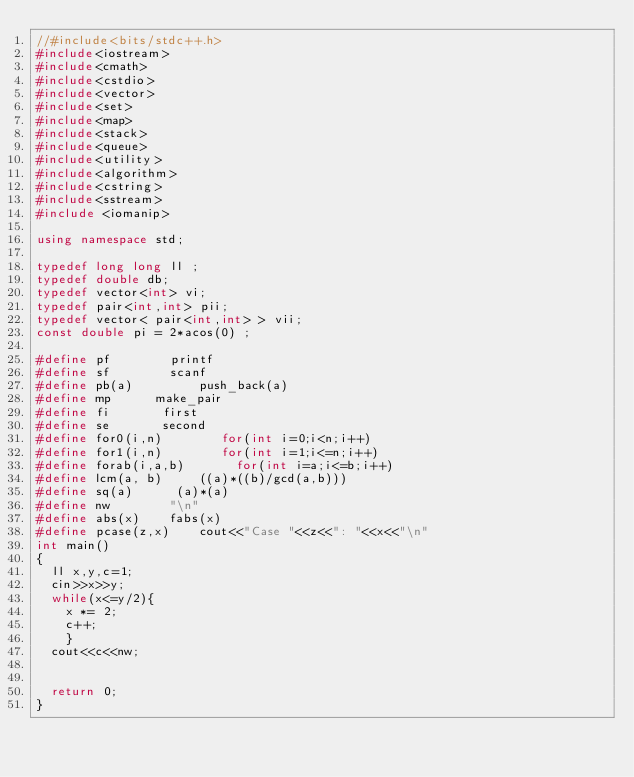<code> <loc_0><loc_0><loc_500><loc_500><_C++_>//#include<bits/stdc++.h>
#include<iostream>
#include<cmath>
#include<cstdio>
#include<vector>
#include<set>
#include<map>
#include<stack>
#include<queue>
#include<utility>
#include<algorithm>
#include<cstring>
#include<sstream>
#include <iomanip>

using namespace std;

typedef long long ll ;
typedef double db;
typedef vector<int> vi;
typedef pair<int,int> pii;
typedef vector< pair<int,int> > vii;
const double pi = 2*acos(0) ;

#define pf		  	printf
#define sf			  scanf
#define pb(a)         push_back(a)
#define mp			make_pair
#define fi			 first
#define se			 second
#define for0(i,n)        for(int i=0;i<n;i++)
#define for1(i,n)        for(int i=1;i<=n;i++)
#define forab(i,a,b)       for(int i=a;i<=b;i++)
#define lcm(a, b)     ((a)*((b)/gcd(a,b)))
#define sq(a)		   (a)*(a)
#define nw				"\n"
#define abs(x)		fabs(x)
#define pcase(z,x)    cout<<"Case "<<z<<": "<<x<<"\n"
int main()
{
	ll x,y,c=1;
	cin>>x>>y;
	while(x<=y/2){
		x *= 2;
		c++;
		}
	cout<<c<<nw;
	
	
	return 0;
}</code> 